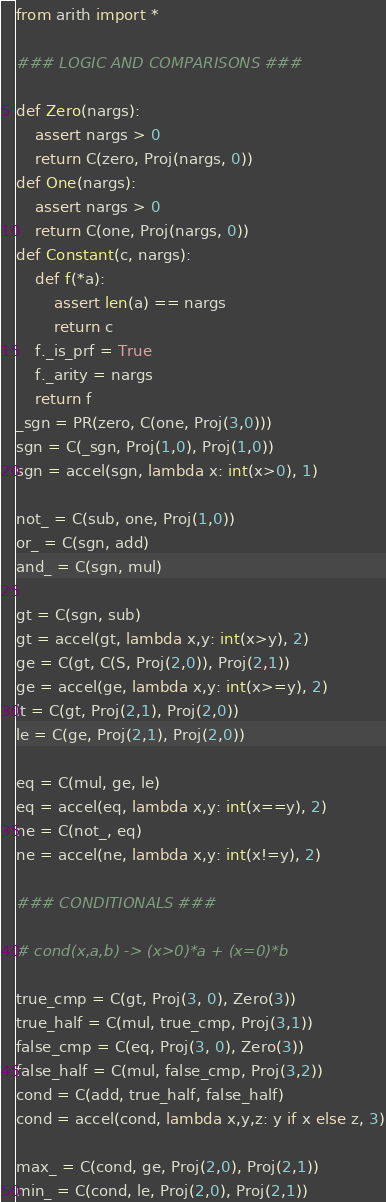Convert code to text. <code><loc_0><loc_0><loc_500><loc_500><_Python_>from arith import *

### LOGIC AND COMPARISONS ###

def Zero(nargs):
    assert nargs > 0
    return C(zero, Proj(nargs, 0))
def One(nargs):
    assert nargs > 0
    return C(one, Proj(nargs, 0))
def Constant(c, nargs):
    def f(*a):
        assert len(a) == nargs
        return c
    f._is_prf = True
    f._arity = nargs
    return f
_sgn = PR(zero, C(one, Proj(3,0)))
sgn = C(_sgn, Proj(1,0), Proj(1,0))
sgn = accel(sgn, lambda x: int(x>0), 1)

not_ = C(sub, one, Proj(1,0))
or_ = C(sgn, add)
and_ = C(sgn, mul)

gt = C(sgn, sub)
gt = accel(gt, lambda x,y: int(x>y), 2)
ge = C(gt, C(S, Proj(2,0)), Proj(2,1))
ge = accel(ge, lambda x,y: int(x>=y), 2)
lt = C(gt, Proj(2,1), Proj(2,0))
le = C(ge, Proj(2,1), Proj(2,0))

eq = C(mul, ge, le)
eq = accel(eq, lambda x,y: int(x==y), 2)
ne = C(not_, eq)
ne = accel(ne, lambda x,y: int(x!=y), 2)

### CONDITIONALS ###

# cond(x,a,b) -> (x>0)*a + (x=0)*b

true_cmp = C(gt, Proj(3, 0), Zero(3))
true_half = C(mul, true_cmp, Proj(3,1))
false_cmp = C(eq, Proj(3, 0), Zero(3))
false_half = C(mul, false_cmp, Proj(3,2))
cond = C(add, true_half, false_half)
cond = accel(cond, lambda x,y,z: y if x else z, 3)

max_ = C(cond, ge, Proj(2,0), Proj(2,1))
min_ = C(cond, le, Proj(2,0), Proj(2,1))
</code> 